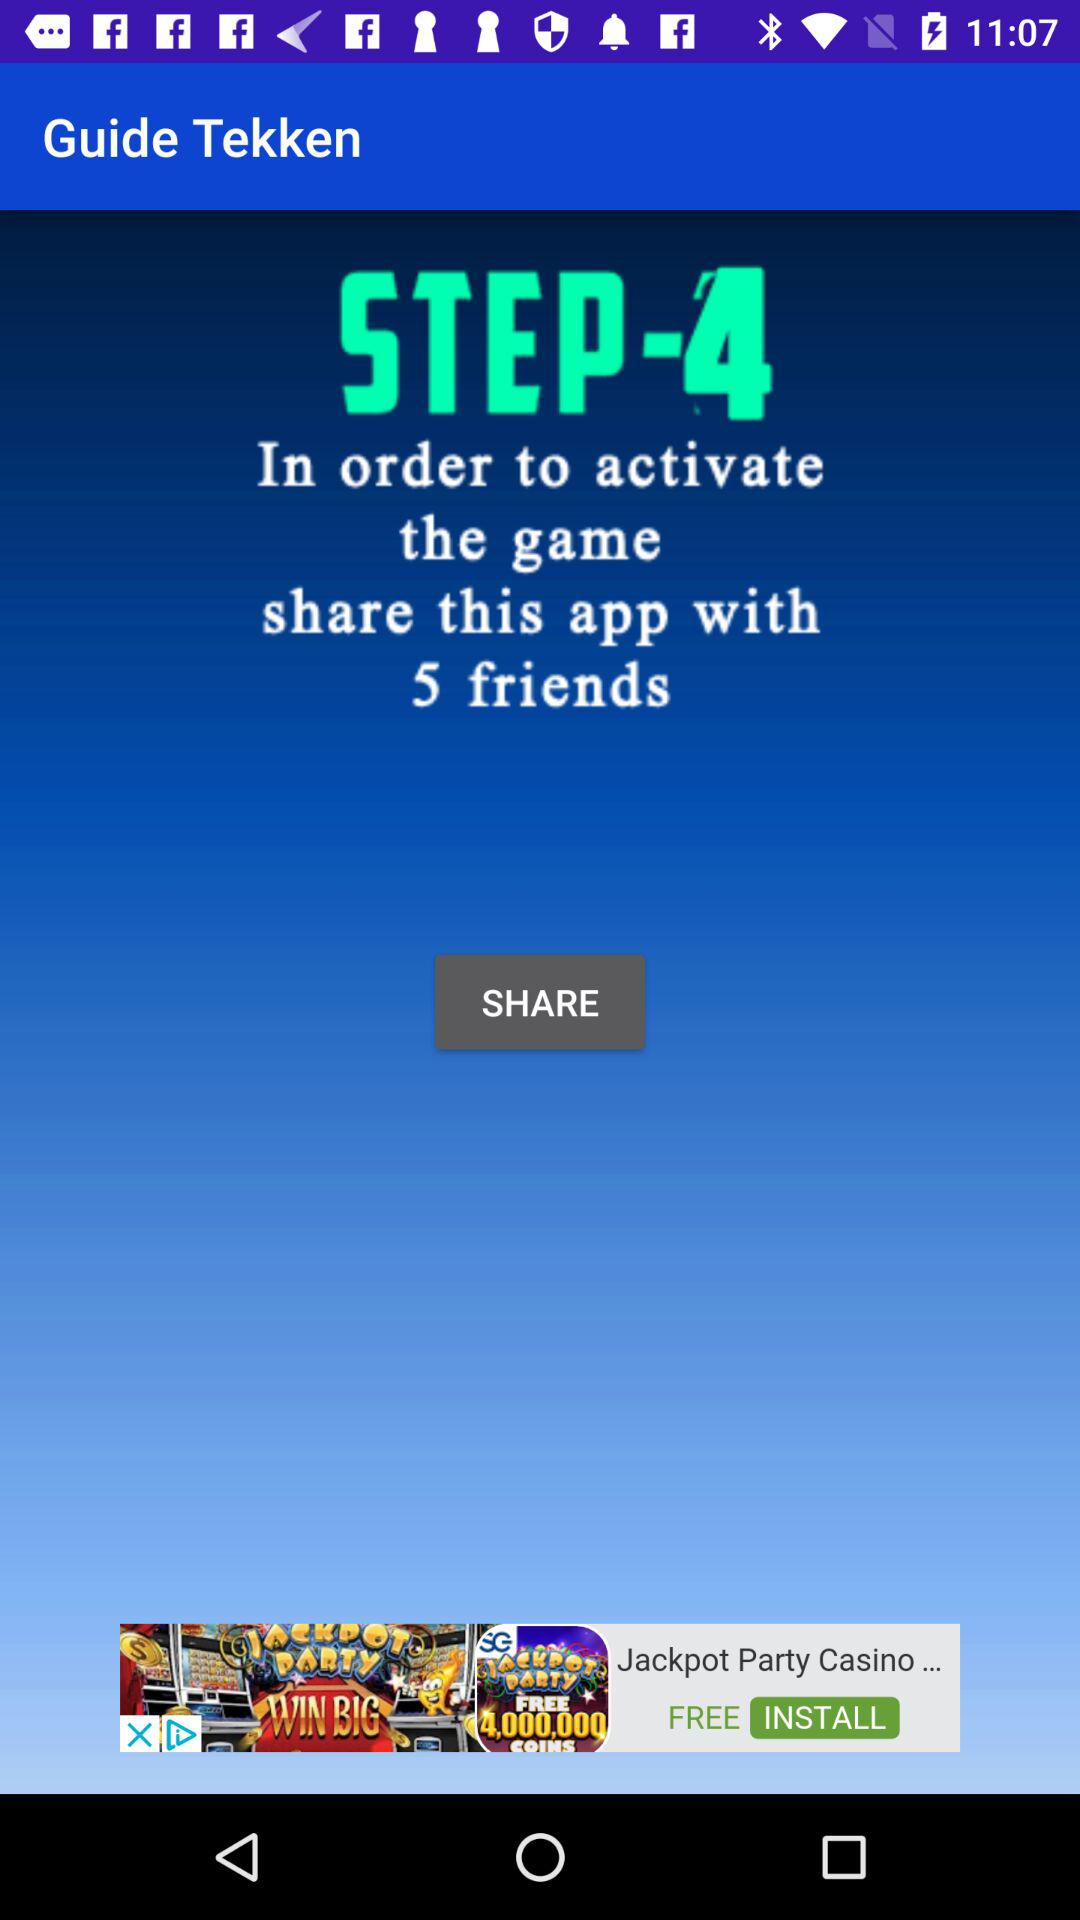What is the number of friends with whom the app needs to be shared for activating the game? The number of friends is 5. 